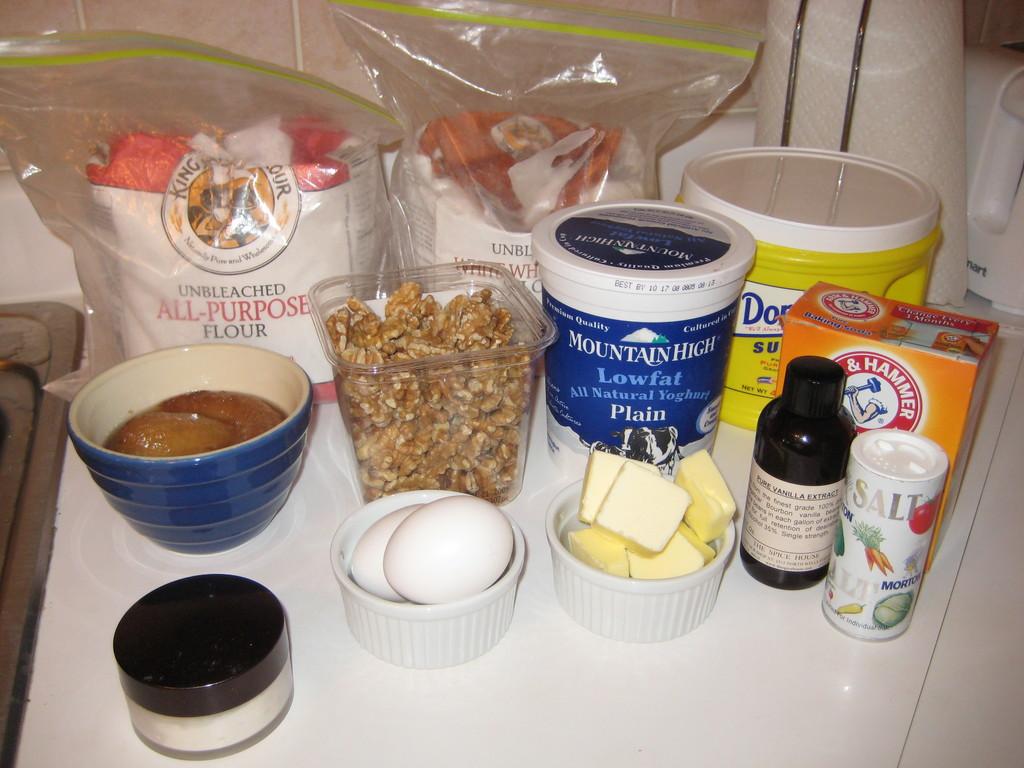What is the brand name of the product in the white and blue pail?
Ensure brevity in your answer.  Mountain high. What is the name of the orange box on the table?
Your answer should be compact. Arm & hammer. 